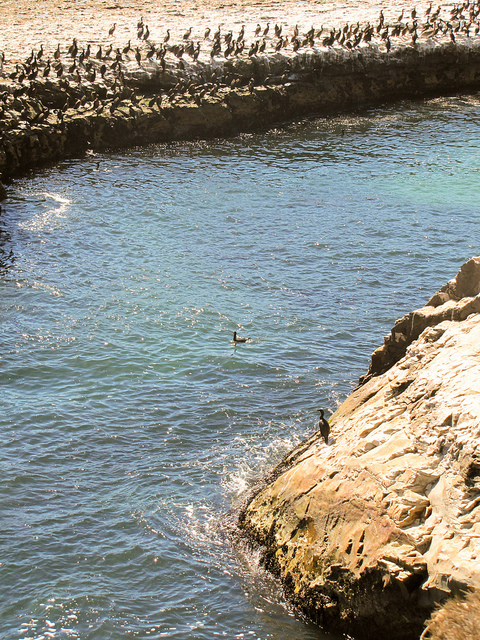What is usually found inside of the large blue item?
A. beef
B. fish
C. flowers
D. soda Typically, the large blue item in the image, which is most likely a container or cooler, would be filled with fish. This is inferred from the aquatic setting and the presence of seabirds that suggests the area may be related to fishing activities. 